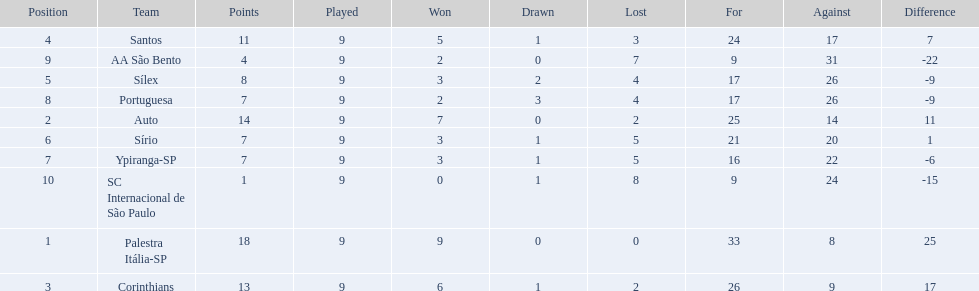How many games did each team play? 9, 9, 9, 9, 9, 9, 9, 9, 9, 9. Did any team score 13 points in the total games they played? 13. What is the name of that team? Corinthians. 